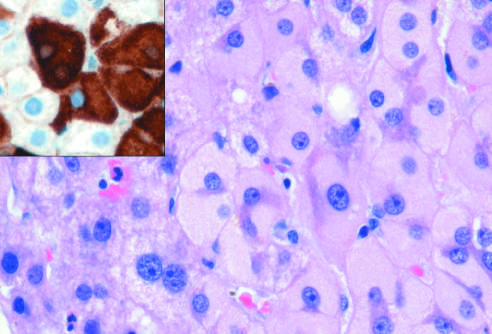does the congested portion of the ileum confirm the presence of surface antigen brown?
Answer the question using a single word or phrase. No 